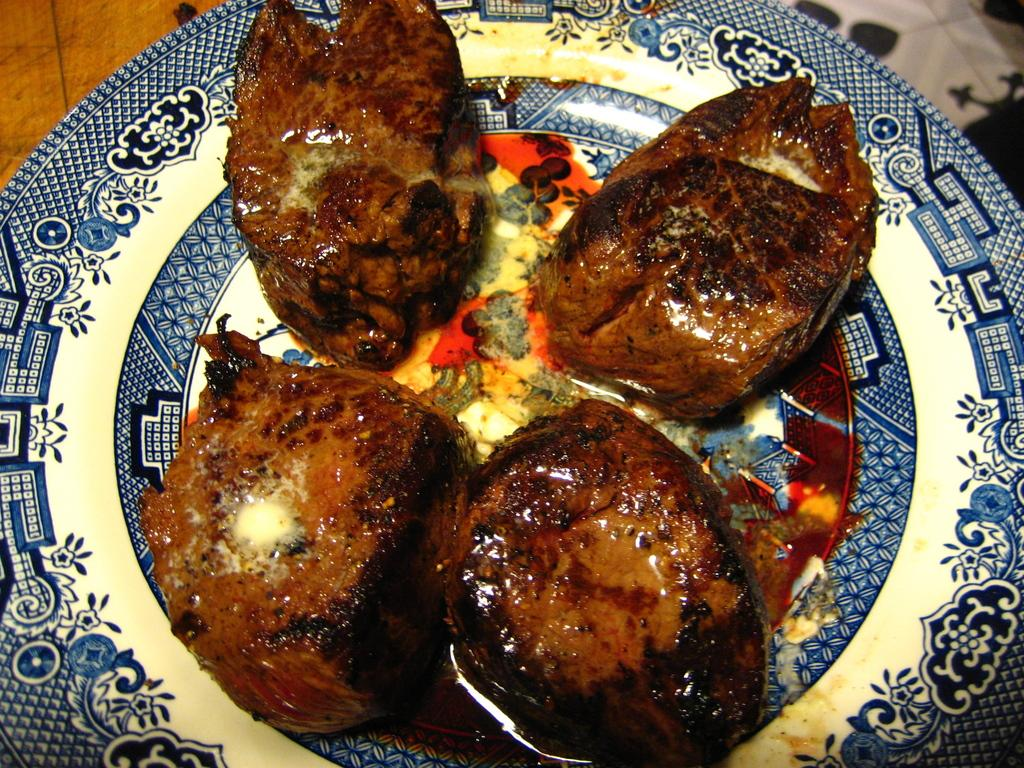What is on the plate that is visible in the image? There is a food item on the plate in the image. What can be observed about the design of the plate? The plate has a blue design. What type of surface is present in the image? Wooden surfaces are present in the image. What type of hill can be seen in the background of the image? There is no hill present in the image; it only features a plate with a food item and wooden surfaces. 